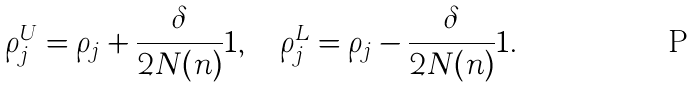<formula> <loc_0><loc_0><loc_500><loc_500>\rho _ { j } ^ { U } = \rho _ { j } + \frac { \delta } { 2 N ( n ) } 1 , \quad \rho _ { j } ^ { L } = \rho _ { j } - \frac { \delta } { 2 N ( n ) } 1 .</formula> 